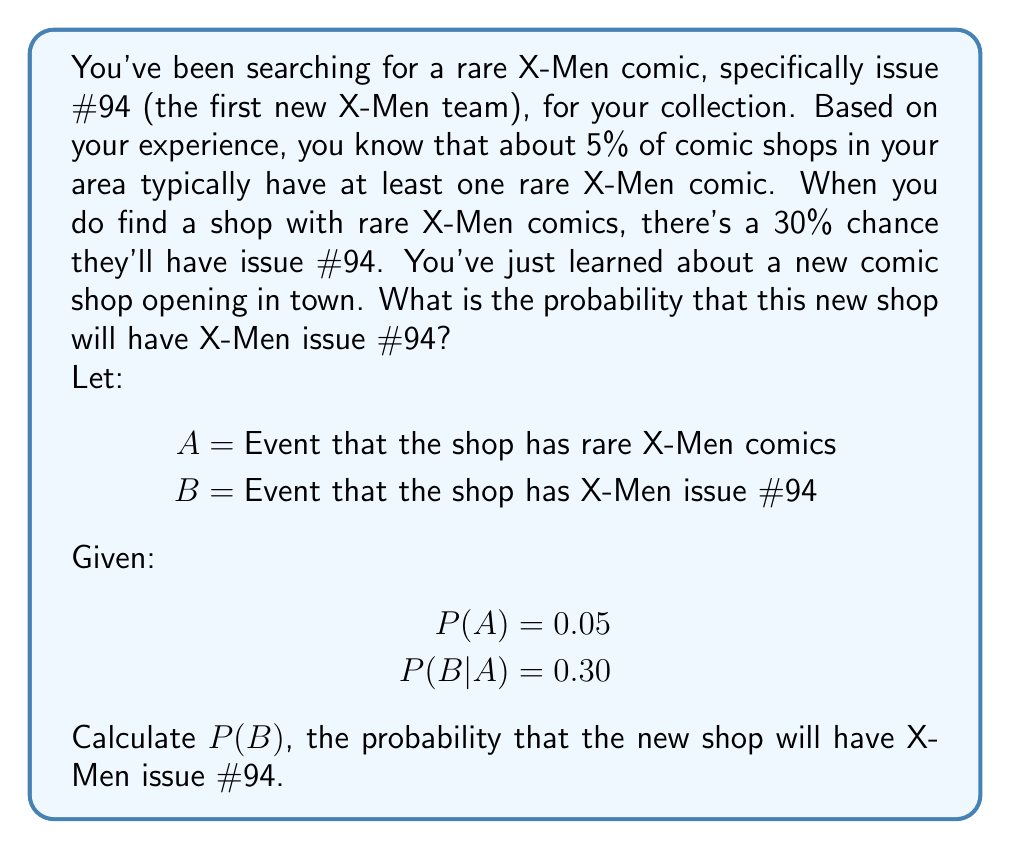Help me with this question. To solve this problem, we'll use the Law of Total Probability. This law states that for events $A$ and $B$:

$$P(B) = P(B|A) \cdot P(A) + P(B|\text{not }A) \cdot P(\text{not }A)$$

We know:
$P(A) = 0.05$ (probability of a shop having rare X-Men comics)
$P(B|A) = 0.30$ (probability of having issue #94 given they have rare X-Men comics)

We need to calculate:
$P(\text{not }A) = 1 - P(A) = 1 - 0.05 = 0.95$

$P(B|\text{not }A)$ is the probability of having issue #94 given they don't have rare X-Men comics. Since issue #94 is considered rare, this probability is 0.

Now we can apply the Law of Total Probability:

$$\begin{align}
P(B) &= P(B|A) \cdot P(A) + P(B|\text{not }A) \cdot P(\text{not }A) \\
&= 0.30 \cdot 0.05 + 0 \cdot 0.95 \\
&= 0.015 + 0 \\
&= 0.015
\end{align}$$

Therefore, the probability that the new shop will have X-Men issue #94 is 0.015 or 1.5%.
Answer: 0.015 or 1.5% 